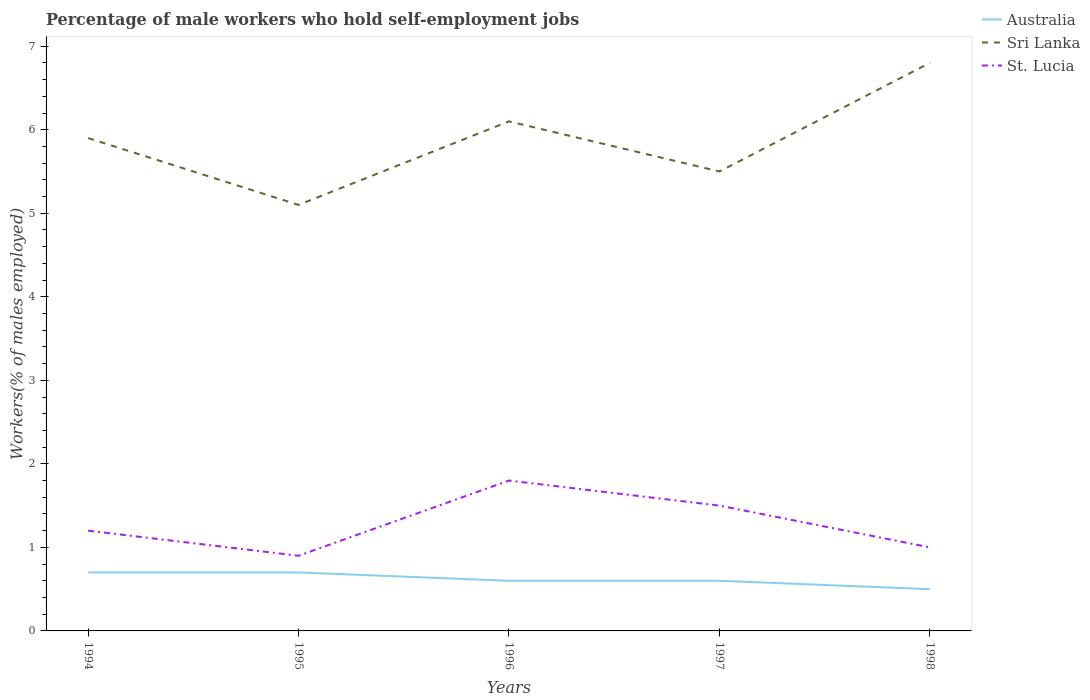How many different coloured lines are there?
Provide a succinct answer. 3. Does the line corresponding to St. Lucia intersect with the line corresponding to Australia?
Offer a terse response. No. Is the number of lines equal to the number of legend labels?
Provide a succinct answer. Yes. Across all years, what is the maximum percentage of self-employed male workers in Sri Lanka?
Keep it short and to the point. 5.1. In which year was the percentage of self-employed male workers in St. Lucia maximum?
Provide a short and direct response. 1995. What is the total percentage of self-employed male workers in Australia in the graph?
Make the answer very short. 0.1. What is the difference between the highest and the second highest percentage of self-employed male workers in Sri Lanka?
Give a very brief answer. 1.7. What is the difference between the highest and the lowest percentage of self-employed male workers in Sri Lanka?
Provide a short and direct response. 3. How many years are there in the graph?
Offer a very short reply. 5. Are the values on the major ticks of Y-axis written in scientific E-notation?
Provide a short and direct response. No. What is the title of the graph?
Offer a very short reply. Percentage of male workers who hold self-employment jobs. What is the label or title of the X-axis?
Offer a very short reply. Years. What is the label or title of the Y-axis?
Your answer should be very brief. Workers(% of males employed). What is the Workers(% of males employed) of Australia in 1994?
Ensure brevity in your answer.  0.7. What is the Workers(% of males employed) of Sri Lanka in 1994?
Keep it short and to the point. 5.9. What is the Workers(% of males employed) in St. Lucia in 1994?
Ensure brevity in your answer.  1.2. What is the Workers(% of males employed) of Australia in 1995?
Your response must be concise. 0.7. What is the Workers(% of males employed) in Sri Lanka in 1995?
Give a very brief answer. 5.1. What is the Workers(% of males employed) in St. Lucia in 1995?
Your answer should be compact. 0.9. What is the Workers(% of males employed) of Australia in 1996?
Offer a very short reply. 0.6. What is the Workers(% of males employed) in Sri Lanka in 1996?
Your response must be concise. 6.1. What is the Workers(% of males employed) of St. Lucia in 1996?
Keep it short and to the point. 1.8. What is the Workers(% of males employed) in Australia in 1997?
Your response must be concise. 0.6. What is the Workers(% of males employed) of Australia in 1998?
Your response must be concise. 0.5. What is the Workers(% of males employed) in Sri Lanka in 1998?
Your answer should be very brief. 6.8. What is the Workers(% of males employed) of St. Lucia in 1998?
Your answer should be compact. 1. Across all years, what is the maximum Workers(% of males employed) in Australia?
Provide a succinct answer. 0.7. Across all years, what is the maximum Workers(% of males employed) in Sri Lanka?
Your answer should be compact. 6.8. Across all years, what is the maximum Workers(% of males employed) in St. Lucia?
Offer a very short reply. 1.8. Across all years, what is the minimum Workers(% of males employed) in Sri Lanka?
Your answer should be compact. 5.1. Across all years, what is the minimum Workers(% of males employed) in St. Lucia?
Ensure brevity in your answer.  0.9. What is the total Workers(% of males employed) in Australia in the graph?
Ensure brevity in your answer.  3.1. What is the total Workers(% of males employed) of Sri Lanka in the graph?
Give a very brief answer. 29.4. What is the difference between the Workers(% of males employed) of Australia in 1994 and that in 1995?
Keep it short and to the point. 0. What is the difference between the Workers(% of males employed) in Sri Lanka in 1994 and that in 1995?
Offer a very short reply. 0.8. What is the difference between the Workers(% of males employed) of Australia in 1994 and that in 1996?
Offer a very short reply. 0.1. What is the difference between the Workers(% of males employed) in Sri Lanka in 1994 and that in 1997?
Your response must be concise. 0.4. What is the difference between the Workers(% of males employed) in St. Lucia in 1994 and that in 1997?
Your response must be concise. -0.3. What is the difference between the Workers(% of males employed) of Sri Lanka in 1994 and that in 1998?
Make the answer very short. -0.9. What is the difference between the Workers(% of males employed) in St. Lucia in 1994 and that in 1998?
Give a very brief answer. 0.2. What is the difference between the Workers(% of males employed) in Australia in 1995 and that in 1996?
Give a very brief answer. 0.1. What is the difference between the Workers(% of males employed) in Sri Lanka in 1995 and that in 1996?
Keep it short and to the point. -1. What is the difference between the Workers(% of males employed) of St. Lucia in 1995 and that in 1996?
Keep it short and to the point. -0.9. What is the difference between the Workers(% of males employed) of Sri Lanka in 1995 and that in 1997?
Your response must be concise. -0.4. What is the difference between the Workers(% of males employed) in Australia in 1995 and that in 1998?
Ensure brevity in your answer.  0.2. What is the difference between the Workers(% of males employed) of Sri Lanka in 1995 and that in 1998?
Make the answer very short. -1.7. What is the difference between the Workers(% of males employed) of St. Lucia in 1995 and that in 1998?
Your answer should be compact. -0.1. What is the difference between the Workers(% of males employed) in Australia in 1996 and that in 1997?
Make the answer very short. 0. What is the difference between the Workers(% of males employed) of St. Lucia in 1996 and that in 1997?
Keep it short and to the point. 0.3. What is the difference between the Workers(% of males employed) in St. Lucia in 1996 and that in 1998?
Your response must be concise. 0.8. What is the difference between the Workers(% of males employed) in Australia in 1997 and that in 1998?
Ensure brevity in your answer.  0.1. What is the difference between the Workers(% of males employed) of Sri Lanka in 1997 and that in 1998?
Make the answer very short. -1.3. What is the difference between the Workers(% of males employed) of Australia in 1994 and the Workers(% of males employed) of Sri Lanka in 1995?
Provide a succinct answer. -4.4. What is the difference between the Workers(% of males employed) in Australia in 1994 and the Workers(% of males employed) in Sri Lanka in 1996?
Give a very brief answer. -5.4. What is the difference between the Workers(% of males employed) in Australia in 1994 and the Workers(% of males employed) in St. Lucia in 1996?
Provide a succinct answer. -1.1. What is the difference between the Workers(% of males employed) of Sri Lanka in 1994 and the Workers(% of males employed) of St. Lucia in 1996?
Keep it short and to the point. 4.1. What is the difference between the Workers(% of males employed) in Australia in 1994 and the Workers(% of males employed) in St. Lucia in 1997?
Keep it short and to the point. -0.8. What is the difference between the Workers(% of males employed) of Sri Lanka in 1994 and the Workers(% of males employed) of St. Lucia in 1997?
Provide a succinct answer. 4.4. What is the difference between the Workers(% of males employed) of Australia in 1994 and the Workers(% of males employed) of St. Lucia in 1998?
Keep it short and to the point. -0.3. What is the difference between the Workers(% of males employed) in Australia in 1995 and the Workers(% of males employed) in Sri Lanka in 1996?
Your response must be concise. -5.4. What is the difference between the Workers(% of males employed) of Sri Lanka in 1995 and the Workers(% of males employed) of St. Lucia in 1996?
Keep it short and to the point. 3.3. What is the difference between the Workers(% of males employed) in Sri Lanka in 1995 and the Workers(% of males employed) in St. Lucia in 1997?
Ensure brevity in your answer.  3.6. What is the difference between the Workers(% of males employed) of Australia in 1995 and the Workers(% of males employed) of St. Lucia in 1998?
Give a very brief answer. -0.3. What is the difference between the Workers(% of males employed) in Australia in 1996 and the Workers(% of males employed) in St. Lucia in 1997?
Your answer should be very brief. -0.9. What is the difference between the Workers(% of males employed) in Sri Lanka in 1996 and the Workers(% of males employed) in St. Lucia in 1997?
Your answer should be compact. 4.6. What is the difference between the Workers(% of males employed) in Australia in 1996 and the Workers(% of males employed) in St. Lucia in 1998?
Your answer should be compact. -0.4. What is the difference between the Workers(% of males employed) in Australia in 1997 and the Workers(% of males employed) in St. Lucia in 1998?
Your response must be concise. -0.4. What is the difference between the Workers(% of males employed) in Sri Lanka in 1997 and the Workers(% of males employed) in St. Lucia in 1998?
Make the answer very short. 4.5. What is the average Workers(% of males employed) in Australia per year?
Offer a terse response. 0.62. What is the average Workers(% of males employed) of Sri Lanka per year?
Ensure brevity in your answer.  5.88. What is the average Workers(% of males employed) in St. Lucia per year?
Offer a very short reply. 1.28. In the year 1994, what is the difference between the Workers(% of males employed) of Australia and Workers(% of males employed) of St. Lucia?
Your answer should be very brief. -0.5. In the year 1994, what is the difference between the Workers(% of males employed) of Sri Lanka and Workers(% of males employed) of St. Lucia?
Offer a very short reply. 4.7. In the year 1996, what is the difference between the Workers(% of males employed) in Australia and Workers(% of males employed) in Sri Lanka?
Keep it short and to the point. -5.5. In the year 1996, what is the difference between the Workers(% of males employed) in Australia and Workers(% of males employed) in St. Lucia?
Provide a succinct answer. -1.2. In the year 1996, what is the difference between the Workers(% of males employed) in Sri Lanka and Workers(% of males employed) in St. Lucia?
Offer a very short reply. 4.3. In the year 1997, what is the difference between the Workers(% of males employed) in Australia and Workers(% of males employed) in Sri Lanka?
Offer a very short reply. -4.9. In the year 1998, what is the difference between the Workers(% of males employed) in Australia and Workers(% of males employed) in Sri Lanka?
Keep it short and to the point. -6.3. In the year 1998, what is the difference between the Workers(% of males employed) in Australia and Workers(% of males employed) in St. Lucia?
Ensure brevity in your answer.  -0.5. What is the ratio of the Workers(% of males employed) of Australia in 1994 to that in 1995?
Your response must be concise. 1. What is the ratio of the Workers(% of males employed) of Sri Lanka in 1994 to that in 1995?
Your response must be concise. 1.16. What is the ratio of the Workers(% of males employed) of St. Lucia in 1994 to that in 1995?
Offer a very short reply. 1.33. What is the ratio of the Workers(% of males employed) of Sri Lanka in 1994 to that in 1996?
Offer a terse response. 0.97. What is the ratio of the Workers(% of males employed) in Australia in 1994 to that in 1997?
Offer a terse response. 1.17. What is the ratio of the Workers(% of males employed) of Sri Lanka in 1994 to that in 1997?
Your answer should be compact. 1.07. What is the ratio of the Workers(% of males employed) in St. Lucia in 1994 to that in 1997?
Your response must be concise. 0.8. What is the ratio of the Workers(% of males employed) of Sri Lanka in 1994 to that in 1998?
Your answer should be compact. 0.87. What is the ratio of the Workers(% of males employed) of Sri Lanka in 1995 to that in 1996?
Your response must be concise. 0.84. What is the ratio of the Workers(% of males employed) in St. Lucia in 1995 to that in 1996?
Offer a very short reply. 0.5. What is the ratio of the Workers(% of males employed) in Sri Lanka in 1995 to that in 1997?
Keep it short and to the point. 0.93. What is the ratio of the Workers(% of males employed) of Sri Lanka in 1995 to that in 1998?
Your response must be concise. 0.75. What is the ratio of the Workers(% of males employed) of St. Lucia in 1995 to that in 1998?
Provide a succinct answer. 0.9. What is the ratio of the Workers(% of males employed) in Sri Lanka in 1996 to that in 1997?
Provide a succinct answer. 1.11. What is the ratio of the Workers(% of males employed) of Sri Lanka in 1996 to that in 1998?
Offer a very short reply. 0.9. What is the ratio of the Workers(% of males employed) of St. Lucia in 1996 to that in 1998?
Make the answer very short. 1.8. What is the ratio of the Workers(% of males employed) in Australia in 1997 to that in 1998?
Make the answer very short. 1.2. What is the ratio of the Workers(% of males employed) of Sri Lanka in 1997 to that in 1998?
Your response must be concise. 0.81. What is the ratio of the Workers(% of males employed) in St. Lucia in 1997 to that in 1998?
Keep it short and to the point. 1.5. What is the difference between the highest and the second highest Workers(% of males employed) of St. Lucia?
Your answer should be compact. 0.3. What is the difference between the highest and the lowest Workers(% of males employed) of Sri Lanka?
Keep it short and to the point. 1.7. 